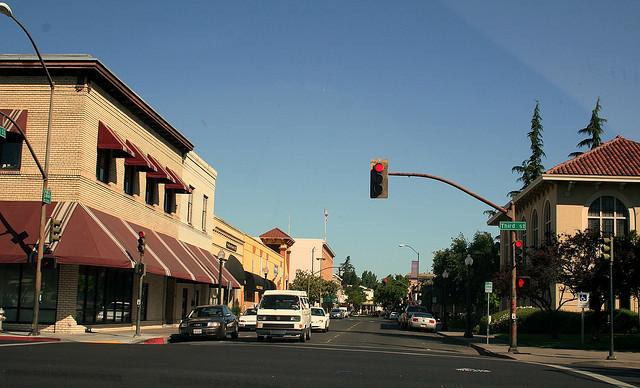From which material is the roofing most visible here sourced?

Choices:
A) clay
B) tar
C) concrete
D) wood clay 